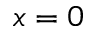Convert formula to latex. <formula><loc_0><loc_0><loc_500><loc_500>x = 0</formula> 